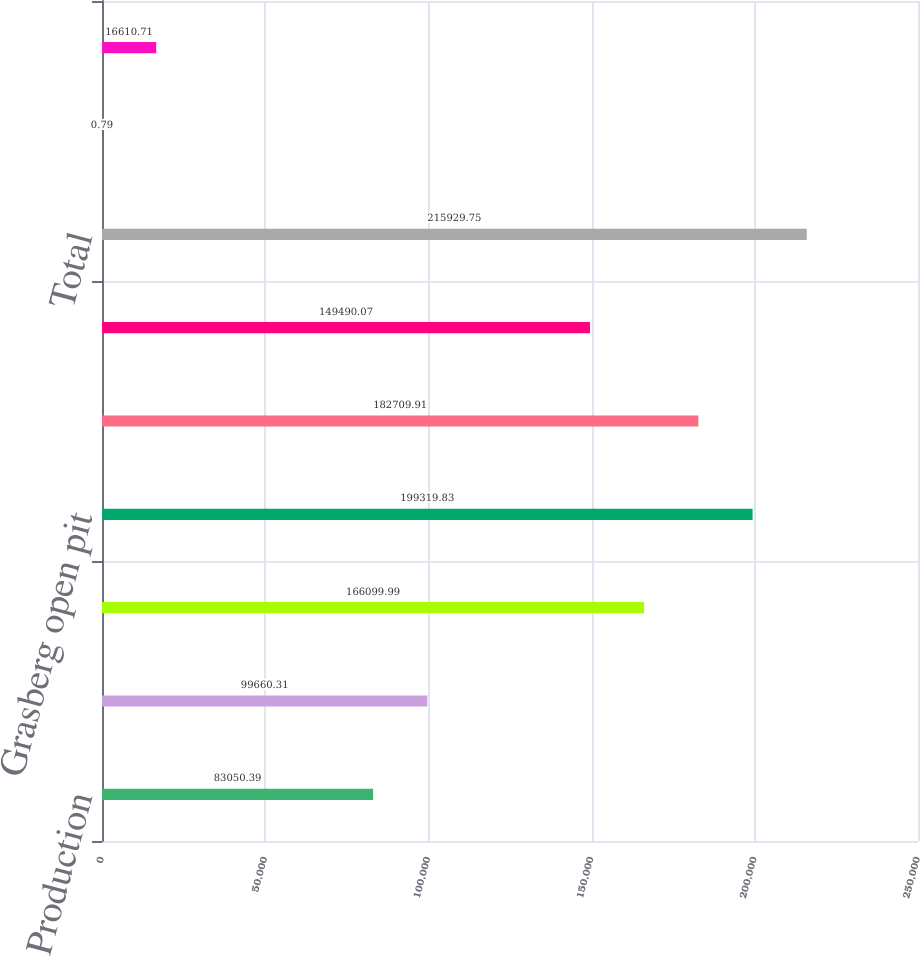<chart> <loc_0><loc_0><loc_500><loc_500><bar_chart><fcel>Production<fcel>Sales<fcel>Average realized price per<fcel>Grasberg open pit<fcel>DOZ underground mine^b<fcel>Big Gossan underground mine^c<fcel>Total<fcel>Copper (percent)<fcel>Gold (grams per metric ton)<nl><fcel>83050.4<fcel>99660.3<fcel>166100<fcel>199320<fcel>182710<fcel>149490<fcel>215930<fcel>0.79<fcel>16610.7<nl></chart> 